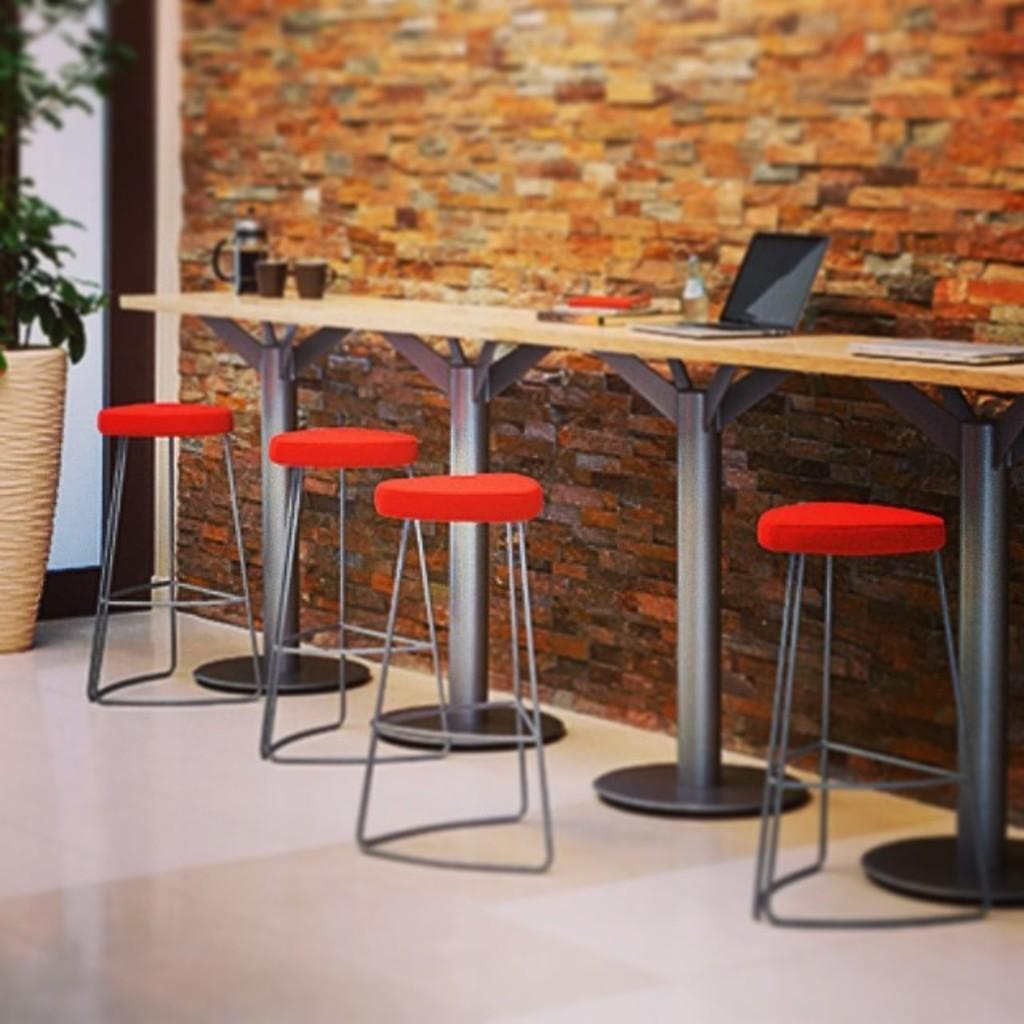What type of furniture is visible in the image? There are chairs in the image. What electronic device can be seen in the image? There is a laptop in the image. What type of containers are present in the image? There are cups and a bottle in the image. What kitchen appliance is visible in the image? There is a kettle in the image. What objects are placed on the table? There are objects on the table, including the laptop, cups, and kettle. What type of greenery is present in the image? There is a house plant in the image. What can be seen in the background of the image? There is a wall and glass in the background of the image. What condition does the trick increase in the image? There is no trick or condition mentioned in the image; it features chairs, a laptop, cups, a kettle, a bottle, objects on the table, a house plant, and a wall with glass in the background. 